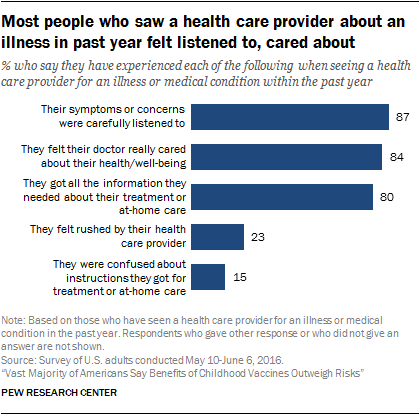Mention a couple of crucial points in this snapshot. The value of the first bar is 87. The largest and smallest bar together have a total value of 102. 